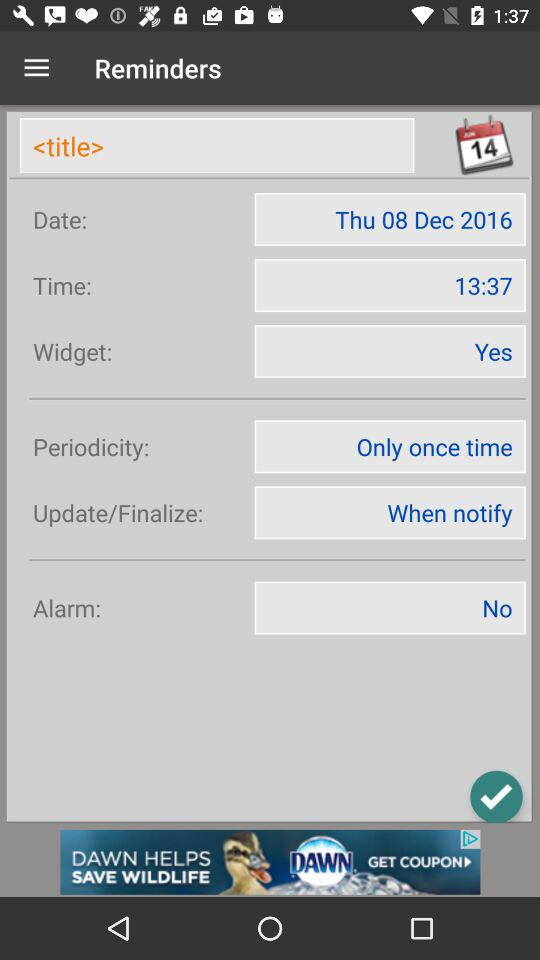What is the given time? The given time is 13.37. 